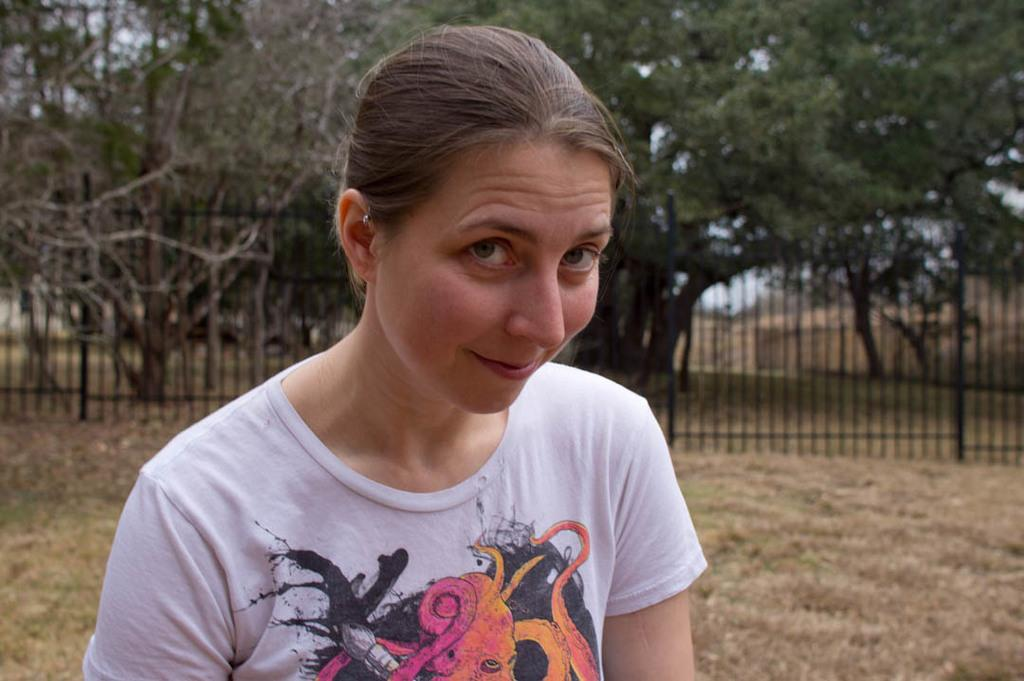What is the main subject in the image? There is a woman standing in the image. What can be seen on the ground in the image? Shredded leaves are present on the ground. What type of barrier is visible in the image? There is a fence in the image. What type of natural environment is visible in the image? Trees are visible in the image. What is visible in the background of the image? The sky is visible in the image. What type of balloon is being held by the woman in the image? There is no balloon present in the image; the woman is not holding anything. 